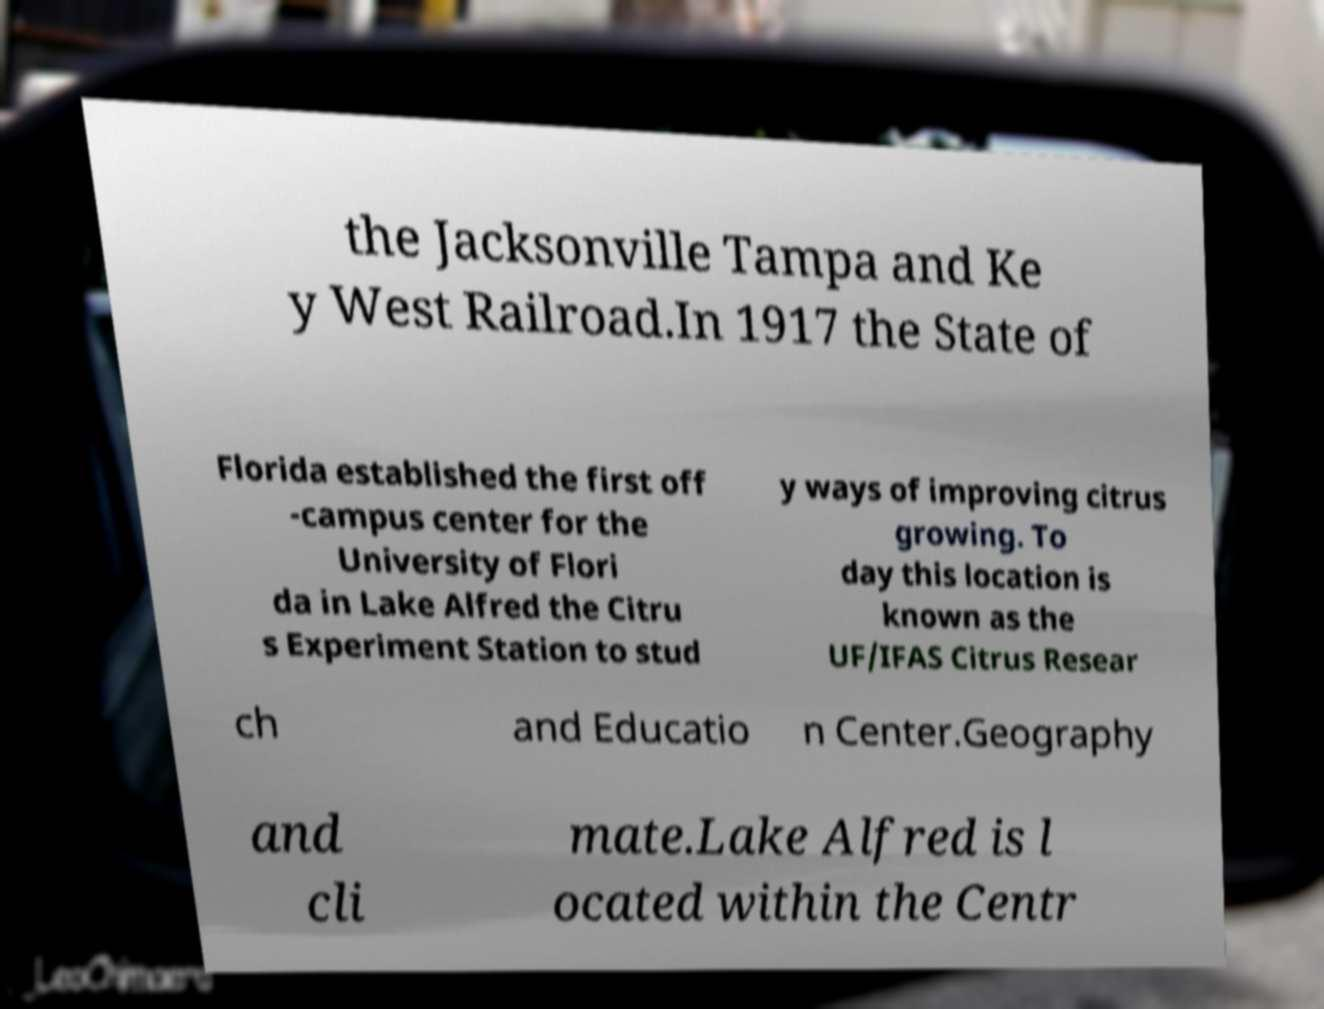What messages or text are displayed in this image? I need them in a readable, typed format. the Jacksonville Tampa and Ke y West Railroad.In 1917 the State of Florida established the first off -campus center for the University of Flori da in Lake Alfred the Citru s Experiment Station to stud y ways of improving citrus growing. To day this location is known as the UF/IFAS Citrus Resear ch and Educatio n Center.Geography and cli mate.Lake Alfred is l ocated within the Centr 